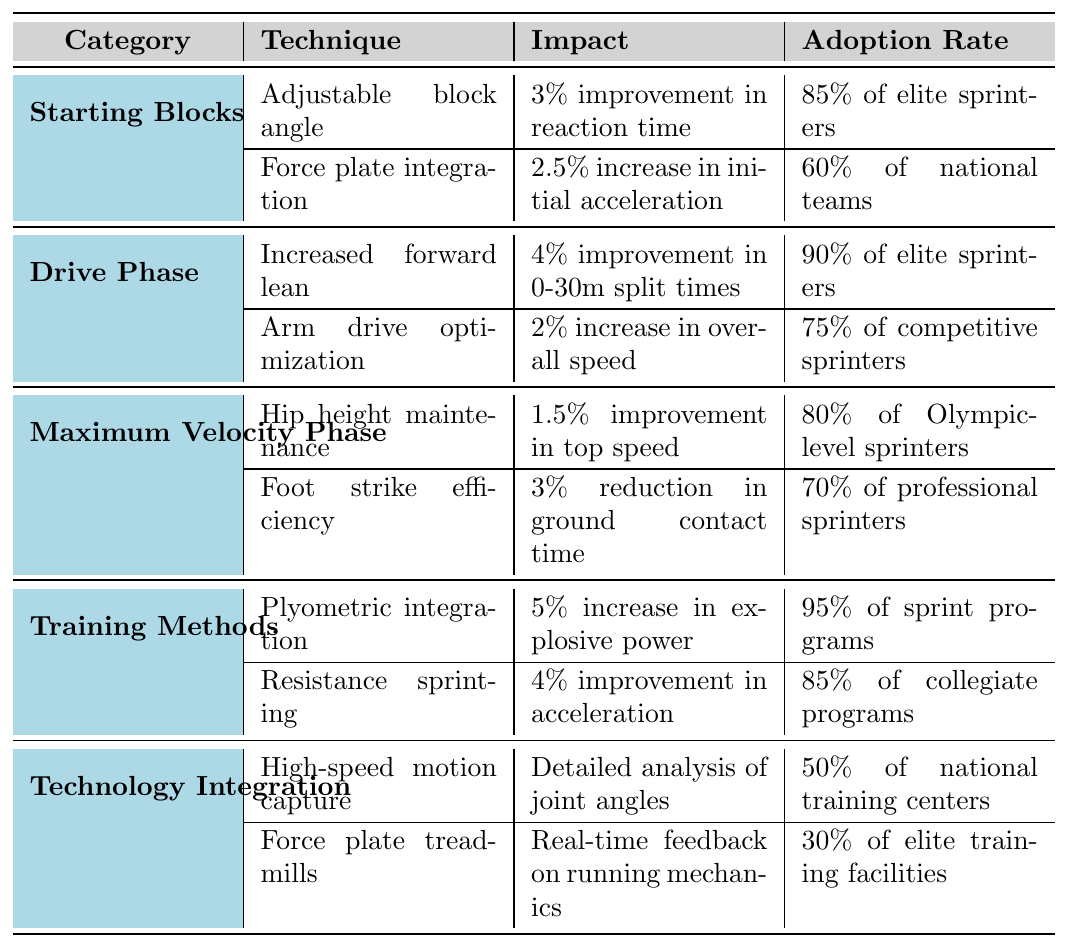What is the technique with the highest adoption rate among elite sprinters? The table shows that the technique "Plyometric integration" under the "Training Methods" category has an adoption rate of 95% of sprint programs, which is the highest among all techniques listed.
Answer: Plyometric integration Which category has the second-highest impact value, and what is that value? The category "Drive Phase" has a technique "Increased forward lean" with a 4% improvement in 0-30m split times, which is the second-highest impact value overall when compared to all impact values listed in the table.
Answer: Drive Phase, 4% Is the adoption rate of "High-speed motion capture" higher than that of "Force plate treadmills"? The adoption rate of "High-speed motion capture" is 50% while "Force plate treadmills" have an adoption rate of 30%. Therefore, "High-speed motion capture" has a higher adoption rate.
Answer: Yes How much improvement in initial acceleration does "Force plate integration" provide compared to the impact of "Hip height maintenance"? "Force plate integration" provides a 2.5% increase in initial acceleration, while "Hip height maintenance" offers a 1.5% improvement in top speed. The difference between them is 2.5 - 1.5 = 1%.
Answer: 1% What percentage of collegiate programs adopt the technique "Resistance sprinting"? The table clearly indicates that "Resistance sprinting" has an adoption rate of 85% among collegiate programs.
Answer: 85% What is the average impact value of the techniques listed under the "Drive Phase"? The techniques listed are "Increased forward lean" (4%) and "Arm drive optimization" (2%). The average impact is (4 + 2) / 2 = 3%.
Answer: 3% How many techniques have an adoption rate of 70% or lower? From the table, "Force plate treadmills" (30%) and "Foot strike efficiency" (70%) are the only techniques with an adoption rate of 70% or lower. This means there are 2 techniques that meet the criteria.
Answer: 2 Which advancement technique has the least impact, and what is that impact? The technique "Hip height maintenance" has the least impact at 1.5% improvement in top speed among all advancements listed in the table.
Answer: Hip height maintenance, 1.5% Are there any techniques under "Technology Integration" with adoption rates above 50%? "High-speed motion capture" has an adoption rate of 50%, which does not exceed it, and "Force plate treadmills" has a lower adoption rate of 30%. Therefore, there are no techniques under this category with adoption rates above 50%.
Answer: No 